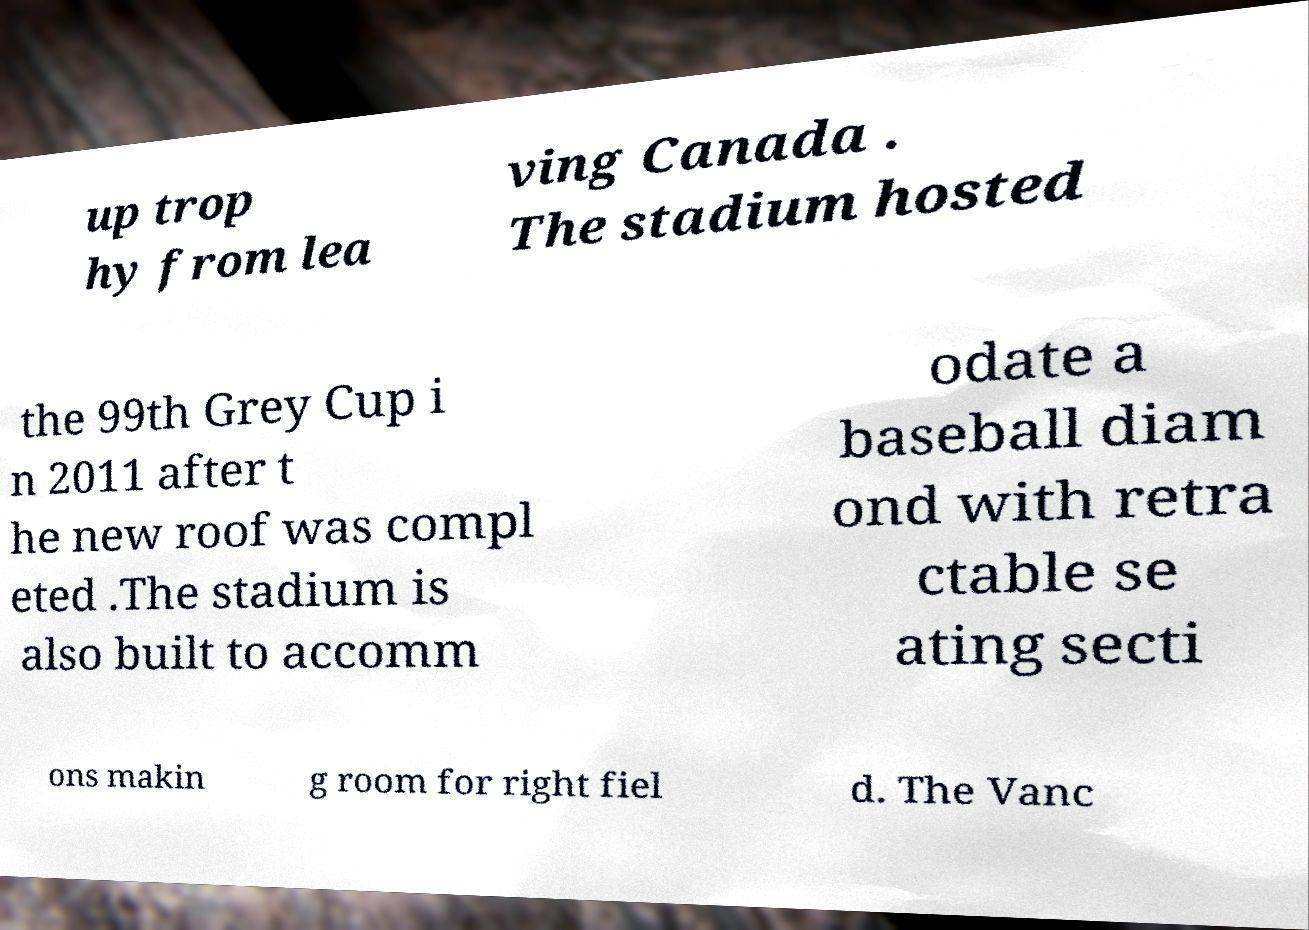What messages or text are displayed in this image? I need them in a readable, typed format. up trop hy from lea ving Canada . The stadium hosted the 99th Grey Cup i n 2011 after t he new roof was compl eted .The stadium is also built to accomm odate a baseball diam ond with retra ctable se ating secti ons makin g room for right fiel d. The Vanc 